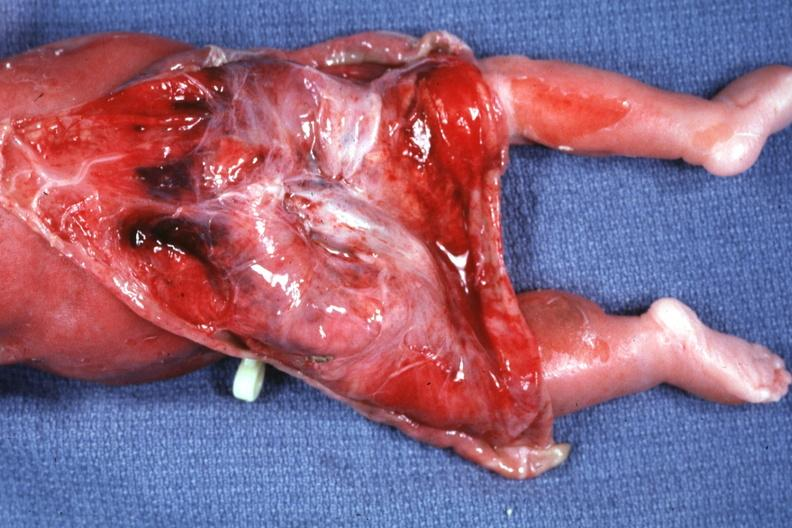what does this image show?
Answer the question using a single word or phrase. Skin over back a buttocks reflected to show large tumor mass 